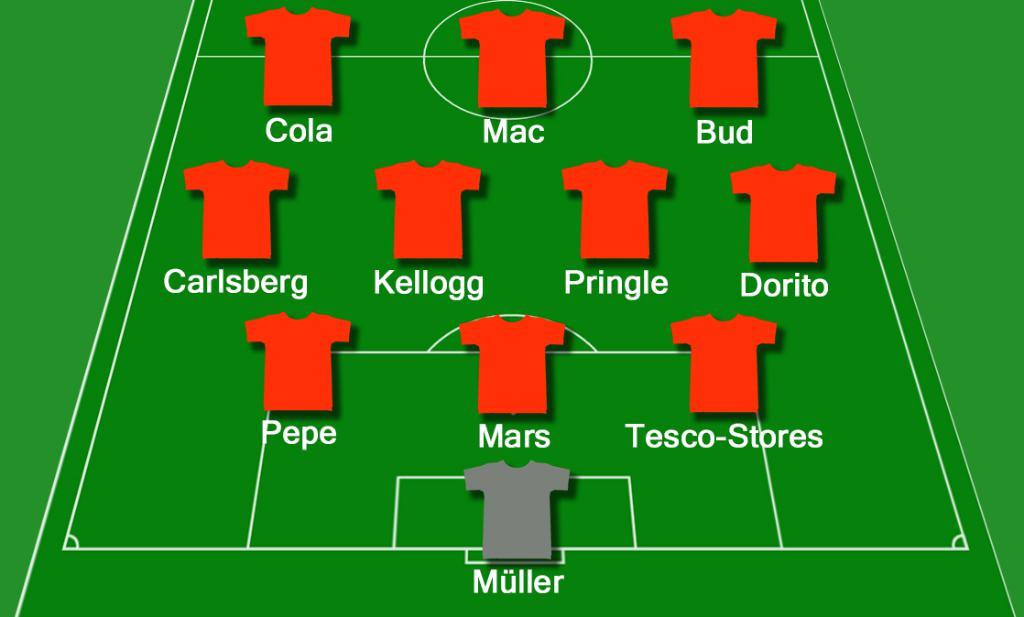What is the name at the center top of the image?
Keep it short and to the point. Mac. How many players are there?
Offer a terse response. Answering does not require reading text in the image. 